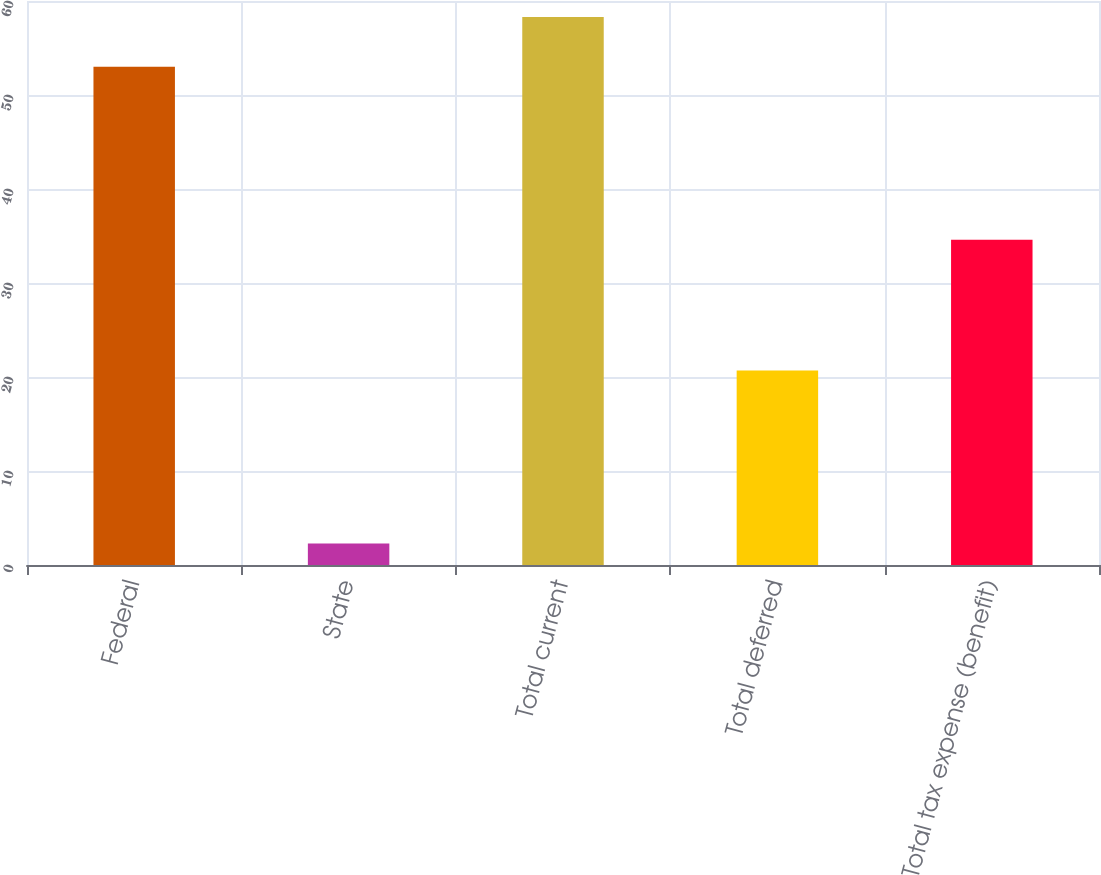<chart> <loc_0><loc_0><loc_500><loc_500><bar_chart><fcel>Federal<fcel>State<fcel>Total current<fcel>Total deferred<fcel>Total tax expense (benefit)<nl><fcel>53<fcel>2.3<fcel>58.3<fcel>20.7<fcel>34.6<nl></chart> 